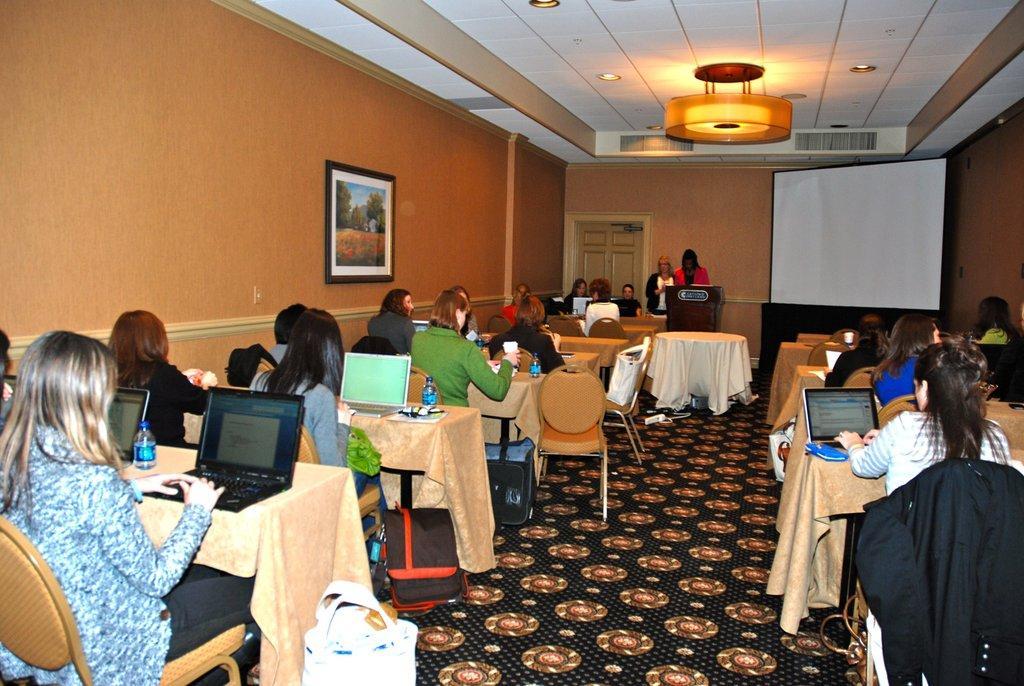How would you summarize this image in a sentence or two? There are people sitting on the chair and working on laptop which is on the table. On the table we can see water bottles,laptops. Here in the middle there is a podium behind it there are two women standing and a door,wall and a screen. On the wall we can see frame. 